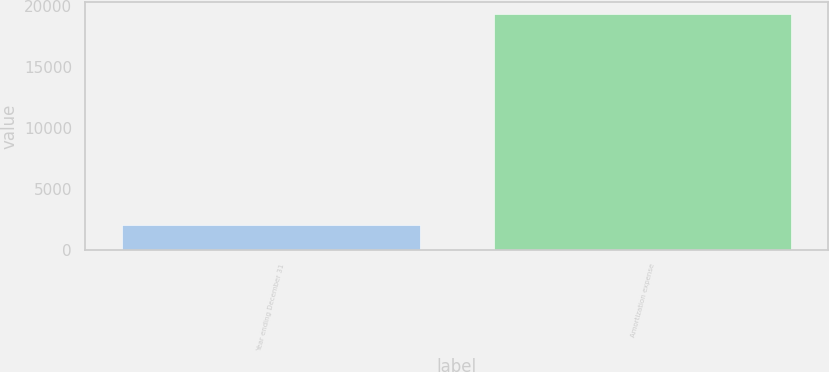Convert chart to OTSL. <chart><loc_0><loc_0><loc_500><loc_500><bar_chart><fcel>Year ending December 31<fcel>Amortization expense<nl><fcel>2022<fcel>19345<nl></chart> 